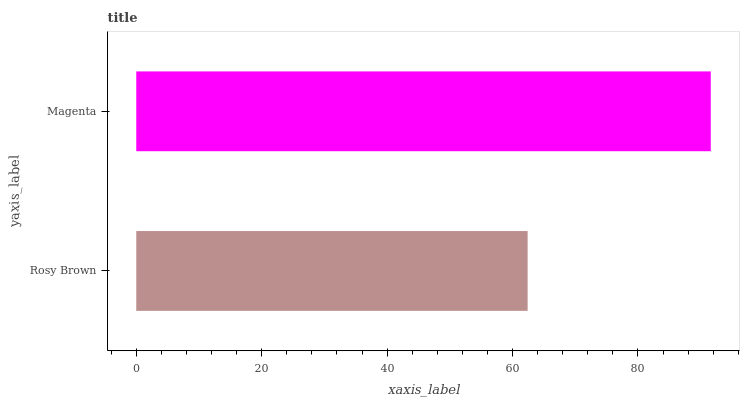Is Rosy Brown the minimum?
Answer yes or no. Yes. Is Magenta the maximum?
Answer yes or no. Yes. Is Magenta the minimum?
Answer yes or no. No. Is Magenta greater than Rosy Brown?
Answer yes or no. Yes. Is Rosy Brown less than Magenta?
Answer yes or no. Yes. Is Rosy Brown greater than Magenta?
Answer yes or no. No. Is Magenta less than Rosy Brown?
Answer yes or no. No. Is Magenta the high median?
Answer yes or no. Yes. Is Rosy Brown the low median?
Answer yes or no. Yes. Is Rosy Brown the high median?
Answer yes or no. No. Is Magenta the low median?
Answer yes or no. No. 